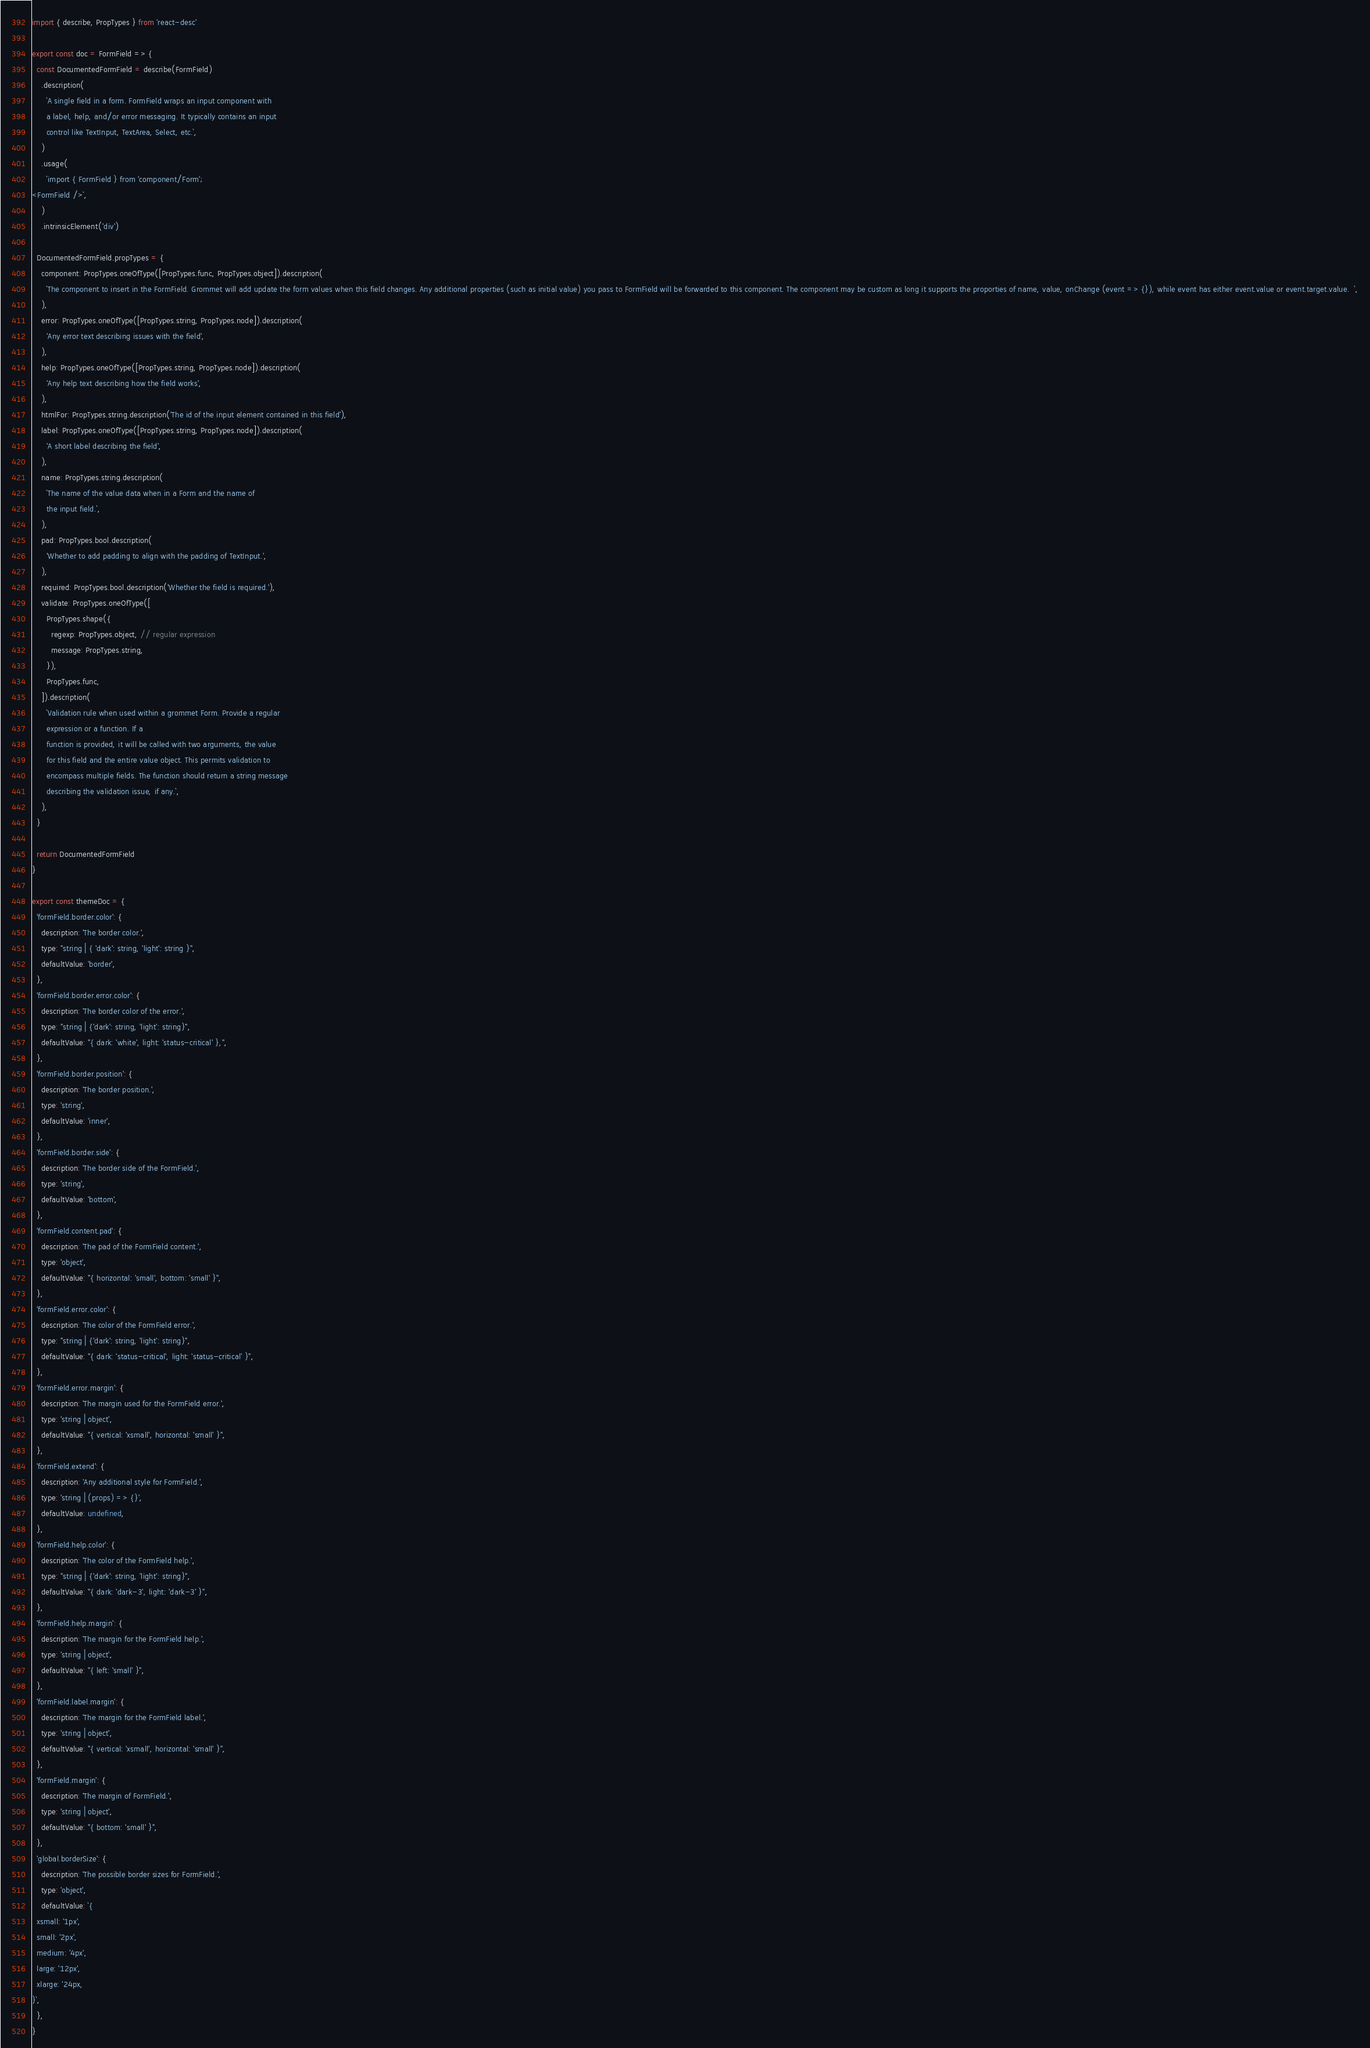<code> <loc_0><loc_0><loc_500><loc_500><_JavaScript_>import { describe, PropTypes } from 'react-desc'

export const doc = FormField => {
  const DocumentedFormField = describe(FormField)
    .description(
      `A single field in a form. FormField wraps an input component with
      a label, help, and/or error messaging. It typically contains an input
      control like TextInput, TextArea, Select, etc.`,
    )
    .usage(
      `import { FormField } from 'component/Form';
<FormField />`,
    )
    .intrinsicElement('div')

  DocumentedFormField.propTypes = {
    component: PropTypes.oneOfType([PropTypes.func, PropTypes.object]).description(
      `The component to insert in the FormField. Grommet will add update the form values when this field changes. Any additional properties (such as initial value) you pass to FormField will be forwarded to this component. The component may be custom as long it supports the proporties of name, value, onChange (event => {}), while event has either event.value or event.target.value.  `,
    ),
    error: PropTypes.oneOfType([PropTypes.string, PropTypes.node]).description(
      'Any error text describing issues with the field',
    ),
    help: PropTypes.oneOfType([PropTypes.string, PropTypes.node]).description(
      'Any help text describing how the field works',
    ),
    htmlFor: PropTypes.string.description('The id of the input element contained in this field'),
    label: PropTypes.oneOfType([PropTypes.string, PropTypes.node]).description(
      'A short label describing the field',
    ),
    name: PropTypes.string.description(
      `The name of the value data when in a Form and the name of
      the input field.`,
    ),
    pad: PropTypes.bool.description(
      'Whether to add padding to align with the padding of TextInput.',
    ),
    required: PropTypes.bool.description('Whether the field is required.'),
    validate: PropTypes.oneOfType([
      PropTypes.shape({
        regexp: PropTypes.object, // regular expression
        message: PropTypes.string,
      }),
      PropTypes.func,
    ]).description(
      `Validation rule when used within a grommet Form. Provide a regular
      expression or a function. If a
      function is provided, it will be called with two arguments, the value
      for this field and the entire value object. This permits validation to
      encompass multiple fields. The function should return a string message
      describing the validation issue, if any.`,
    ),
  }

  return DocumentedFormField
}

export const themeDoc = {
  'formField.border.color': {
    description: 'The border color.',
    type: "string | { 'dark': string, 'light': string }",
    defaultValue: 'border',
  },
  'formField.border.error.color': {
    description: 'The border color of the error.',
    type: "string | {'dark': string, 'light': string}",
    defaultValue: "{ dark: 'white', light: 'status-critical' },",
  },
  'formField.border.position': {
    description: 'The border position.',
    type: 'string',
    defaultValue: 'inner',
  },
  'formField.border.side': {
    description: 'The border side of the FormField.',
    type: 'string',
    defaultValue: 'bottom',
  },
  'formField.content.pad': {
    description: 'The pad of the FormField content.',
    type: 'object',
    defaultValue: "{ horizontal: 'small', bottom: 'small' }",
  },
  'formField.error.color': {
    description: 'The color of the FormField error.',
    type: "string | {'dark': string, 'light': string}",
    defaultValue: "{ dark: 'status-critical', light: 'status-critical' }",
  },
  'formField.error.margin': {
    description: 'The margin used for the FormField error.',
    type: 'string | object',
    defaultValue: "{ vertical: 'xsmall', horizontal: 'small' }",
  },
  'formField.extend': {
    description: 'Any additional style for FormField.',
    type: 'string | (props) => {}',
    defaultValue: undefined,
  },
  'formField.help.color': {
    description: 'The color of the FormField help.',
    type: "string | {'dark': string, 'light': string}",
    defaultValue: "{ dark: 'dark-3', light: 'dark-3' }",
  },
  'formField.help.margin': {
    description: 'The margin for the FormField help.',
    type: 'string | object',
    defaultValue: "{ left: 'small' }",
  },
  'formField.label.margin': {
    description: 'The margin for the FormField label.',
    type: 'string | object',
    defaultValue: "{ vertical: 'xsmall', horizontal: 'small' }",
  },
  'formField.margin': {
    description: 'The margin of FormField.',
    type: 'string | object',
    defaultValue: "{ bottom: 'small' }",
  },
  'global.borderSize': {
    description: 'The possible border sizes for FormField.',
    type: 'object',
    defaultValue: `{
  xsmall: '1px',
  small: '2px',
  medium: '4px',
  large: '12px',
  xlarge: '24px,
}`,
  },
}
</code> 